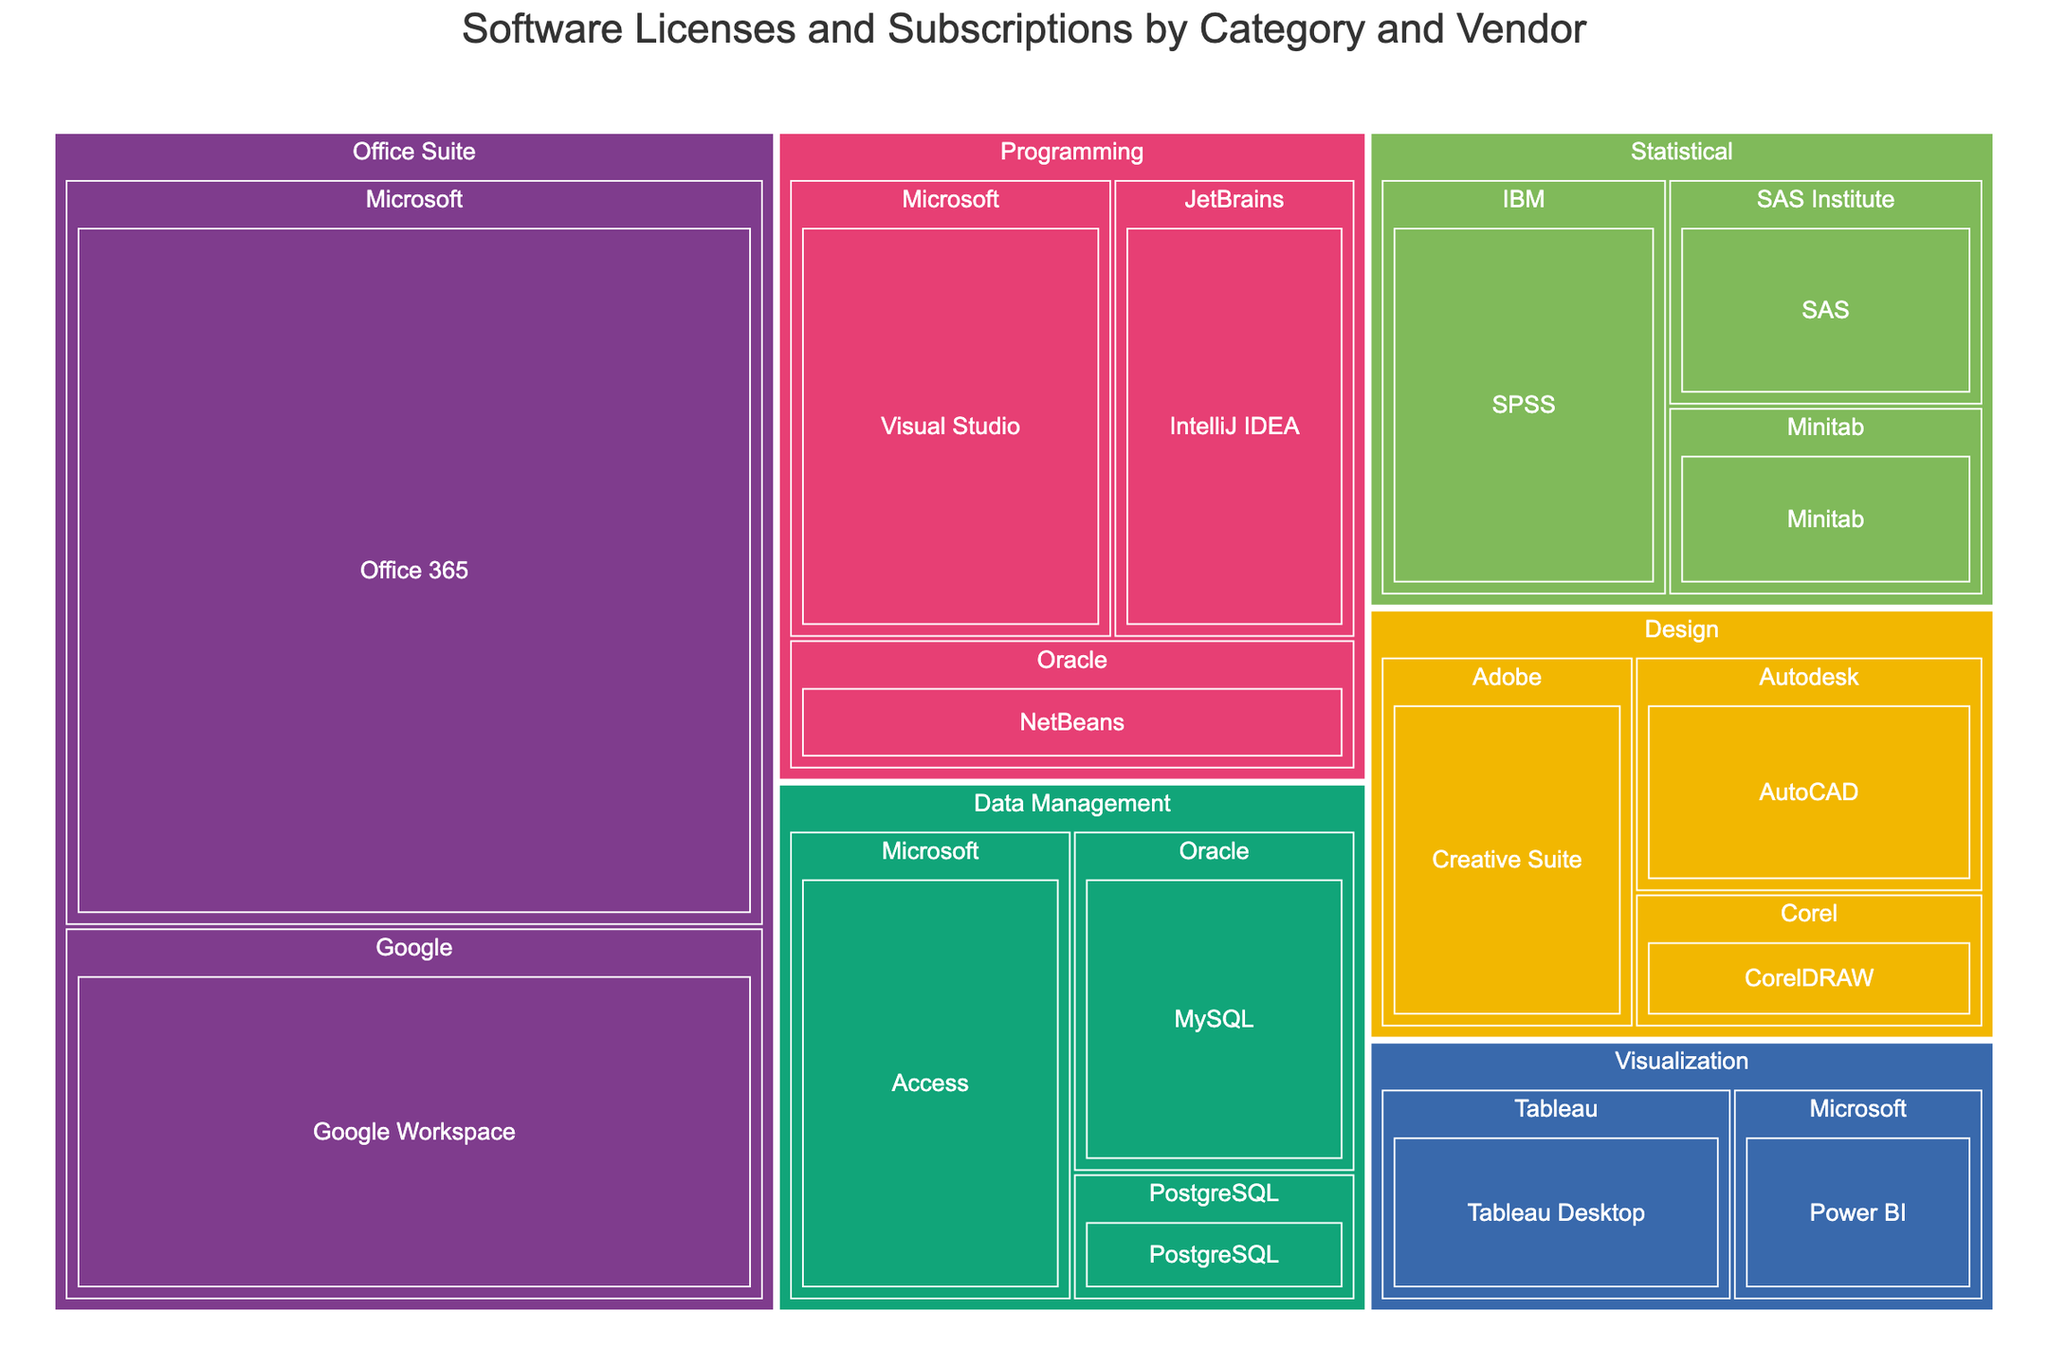What is the total number of licenses for statistical software? To determine the total number of licenses for statistical software, identify all entries under the "Statistical" category and sum their license counts: SPSS (50), SAS (30), and Minitab (25). Therefore, the total is 50 + 30 + 25.
Answer: 105 Which vendor has the most licenses for office suite software? Look under the "Office Suite" category and compare the license counts for each vendor. Microsoft has 200 licenses for Office 365, and Google has 100 licenses for Google Workspace.
Answer: Microsoft How many more licenses are there for Visual Studio compared to NetBeans? Find the number of licenses for Visual Studio (60) and NetBeans (30). Subtract the number of licenses for NetBeans from Visual Studio: 60 - 30.
Answer: 30 Which category has the highest total number of licenses? Sum the licenses for each category and compare: Statistical (50+30+25), Design (40+35+20), Programming (60+45+30), Data Management (55+40+15), Office Suite (200+100), Visualization (35+25). Calculate totals: Statistical (105), Design (95), Programming (135), Data Management (110), Office Suite (300), Visualization (60). Office Suite has the highest total.
Answer: Office Suite Is there any category where all vendors have an equal number of licenses? Review the licenses of each vendor within each category to check for equality: Statistical (IBM 50, SAS Institute 30, Minitab 25), Design (Adobe 40, Autodesk 35, Corel 20), Programming (Microsoft 60, JetBrains 45, Oracle 30), Data Management (Microsoft 55, Oracle 40, PostgreSQL 15), Office Suite (Microsoft 200, Google 100), Visualization (Tableau 35, Microsoft 25). No category has equal licenses for all vendors.
Answer: No Which software has the second-highest number of licenses in the Data Management category? Within the Data Management category, list software by their license counts in descending order: Microsoft Access (55), Oracle MySQL (40), PostgreSQL (15). The second-highest is Oracle MySQL.
Answer: Oracle MySQL How many total vendors are there in the entire treemap? Count the unique vendors listed across all categories in the treemap: IBM, SAS Institute, Minitab, Adobe, Autodesk, Corel, Microsoft, JetBrains, Oracle, Google, Tableau, PostgreSQL.
Answer: 12 What is the difference in the number of licenses between the category with the most licenses and the one with the least? Determine the total number of licenses per category and note the highest (Office Suite, 300) and the lowest (Visualization, 60). Calculate the difference: 300 - 60.
Answer: 240 Which statistical software has the fewest licenses? Identify the software in the statistical category and their respective licenses: SPSS (50), SAS (30), Minitab (25). Minitab has the fewest licenses.
Answer: Minitab 